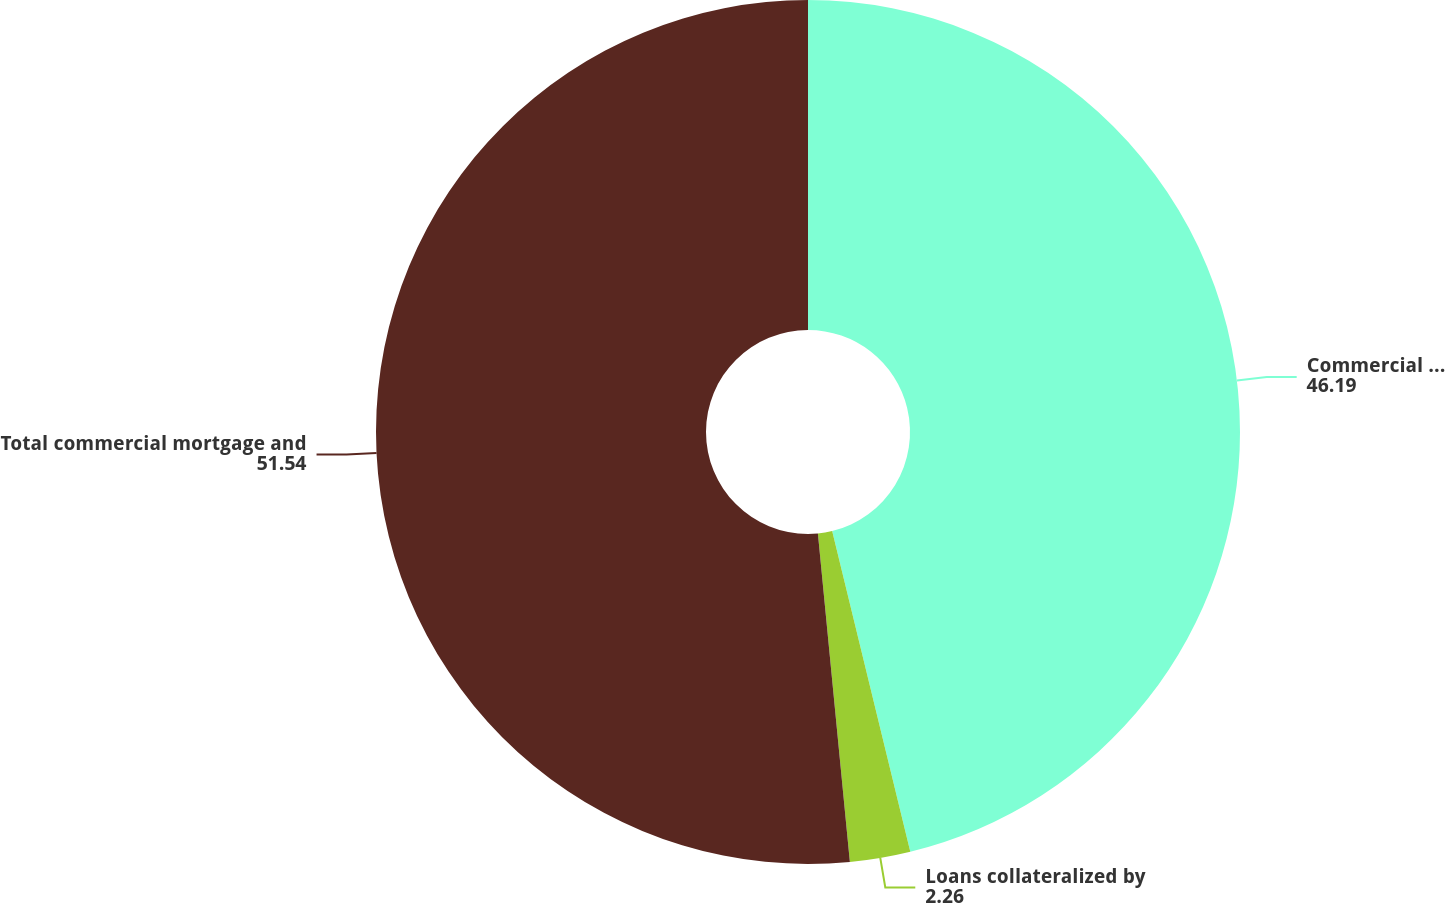Convert chart. <chart><loc_0><loc_0><loc_500><loc_500><pie_chart><fcel>Commercial mortgage loans<fcel>Loans collateralized by<fcel>Total commercial mortgage and<nl><fcel>46.19%<fcel>2.26%<fcel>51.54%<nl></chart> 